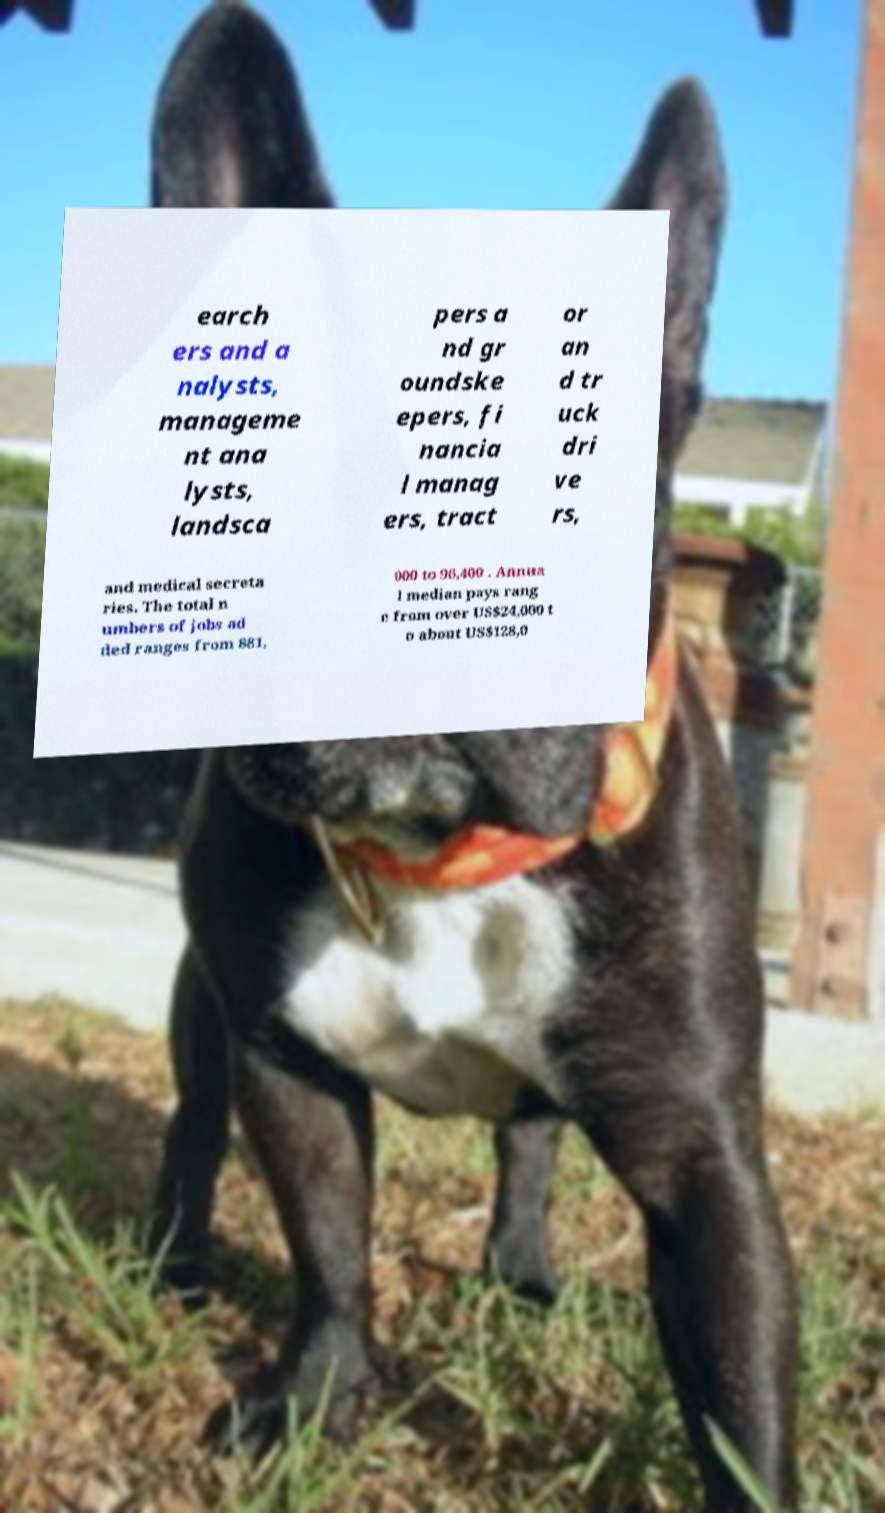What messages or text are displayed in this image? I need them in a readable, typed format. earch ers and a nalysts, manageme nt ana lysts, landsca pers a nd gr oundske epers, fi nancia l manag ers, tract or an d tr uck dri ve rs, and medical secreta ries. The total n umbers of jobs ad ded ranges from 881, 000 to 96,400 . Annua l median pays rang e from over US$24,000 t o about US$128,0 